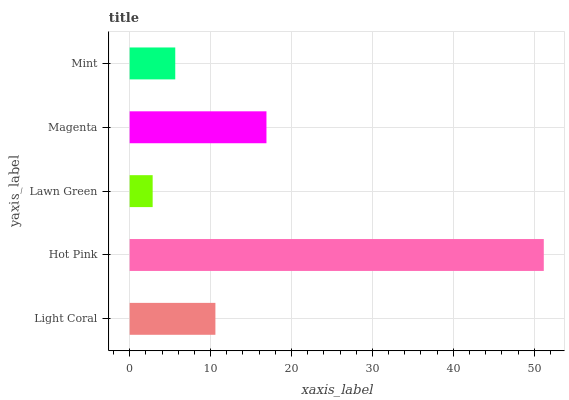Is Lawn Green the minimum?
Answer yes or no. Yes. Is Hot Pink the maximum?
Answer yes or no. Yes. Is Hot Pink the minimum?
Answer yes or no. No. Is Lawn Green the maximum?
Answer yes or no. No. Is Hot Pink greater than Lawn Green?
Answer yes or no. Yes. Is Lawn Green less than Hot Pink?
Answer yes or no. Yes. Is Lawn Green greater than Hot Pink?
Answer yes or no. No. Is Hot Pink less than Lawn Green?
Answer yes or no. No. Is Light Coral the high median?
Answer yes or no. Yes. Is Light Coral the low median?
Answer yes or no. Yes. Is Lawn Green the high median?
Answer yes or no. No. Is Magenta the low median?
Answer yes or no. No. 